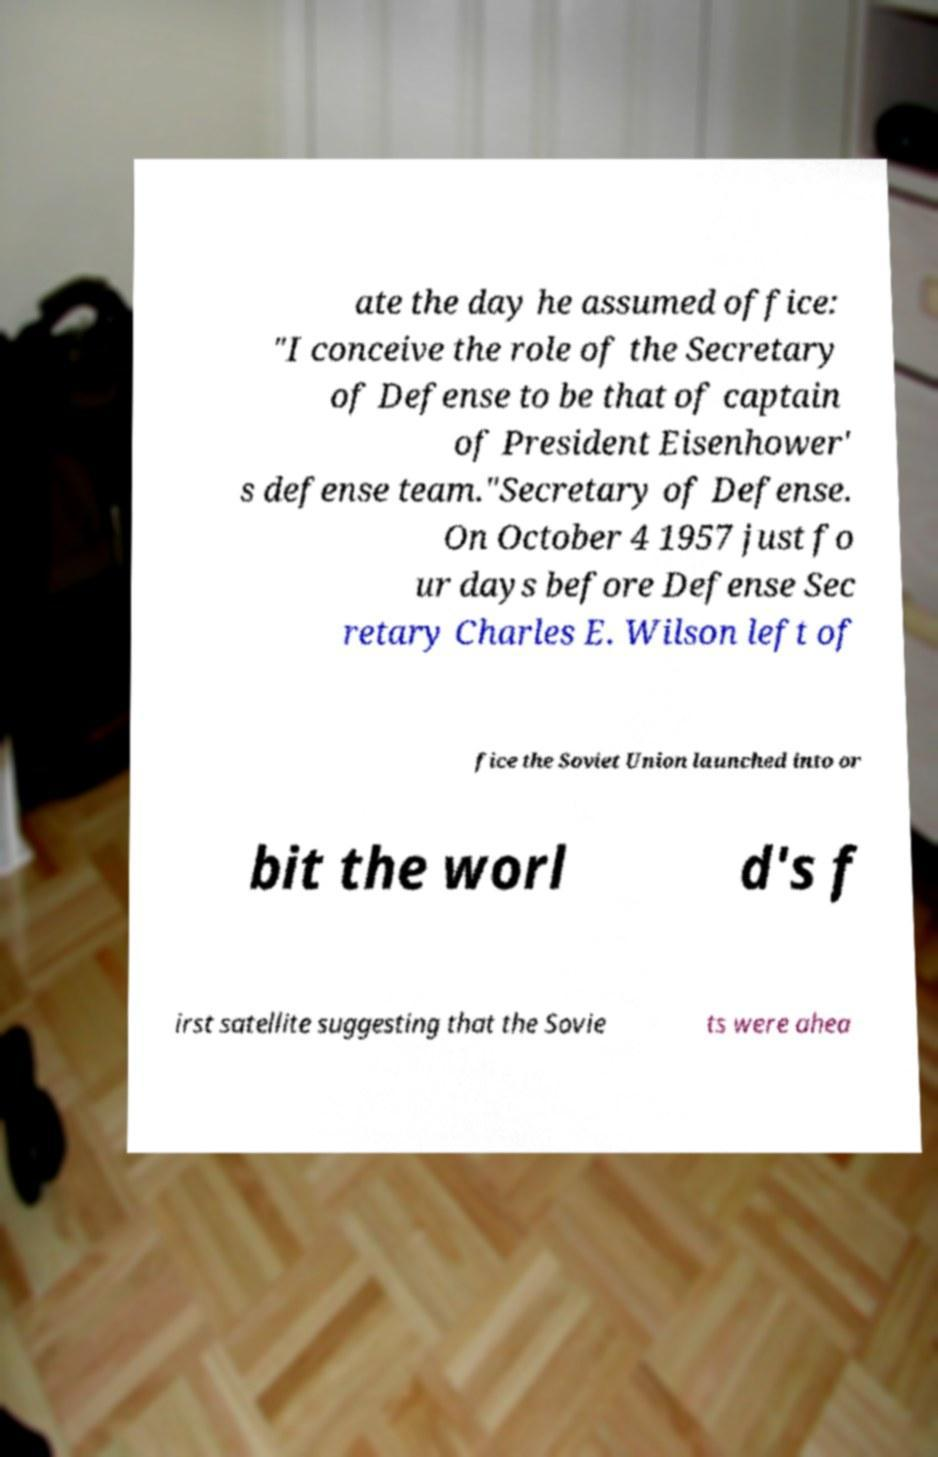Could you extract and type out the text from this image? ate the day he assumed office: "I conceive the role of the Secretary of Defense to be that of captain of President Eisenhower' s defense team."Secretary of Defense. On October 4 1957 just fo ur days before Defense Sec retary Charles E. Wilson left of fice the Soviet Union launched into or bit the worl d's f irst satellite suggesting that the Sovie ts were ahea 